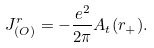<formula> <loc_0><loc_0><loc_500><loc_500>J ^ { r } _ { ( O ) } = - \frac { e ^ { 2 } } { 2 \pi } A _ { t } ( r _ { + } ) .</formula> 